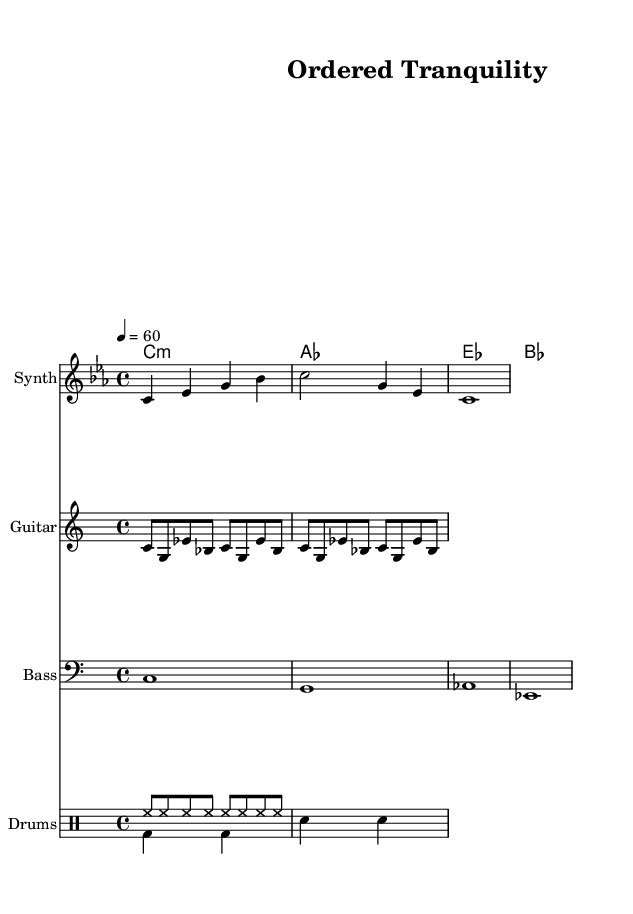What is the key signature of this music? The key signature shown is C minor, which is indicated by the information in the global section that specifies "c \minor".
Answer: C minor What is the time signature of this music? The time signature is 4/4, which is clearly stated in the global section of the code with "\time 4/4".
Answer: 4/4 What is the tempo? The tempo is set at 60 beats per minute, as indicated by the command "\tempo 4 = 60" in the global section.
Answer: 60 How many measures are in the melody? By counting the distinct sets of notes separated by bar lines in the melody section, we find there are three measures present in the melody.
Answer: 3 Which instrument is designated for the bass part? The bass part is notated under the staff labeled "Bass", as seen in the instrument name annotation placed with "\new Staff \with { instrumentName = "Bass" }".
Answer: Bass What type of rhythm is represented in the drum pattern? The drum pattern consists of a mixture of high hats and bass drums, along with snare, characterized by steady beats indicated in both drum sections titled "drumPatternUp" and "drumPatternDown".
Answer: Fusion of beats Describe the overall feel of the music piece by genre. The piece is labeled as "Ordered Tranquility" and combines elements of ambient and industrial music, indicated by the structure and melodic choices present in the score, giving it a serene yet organized feel.
Answer: Ambient-industrial 